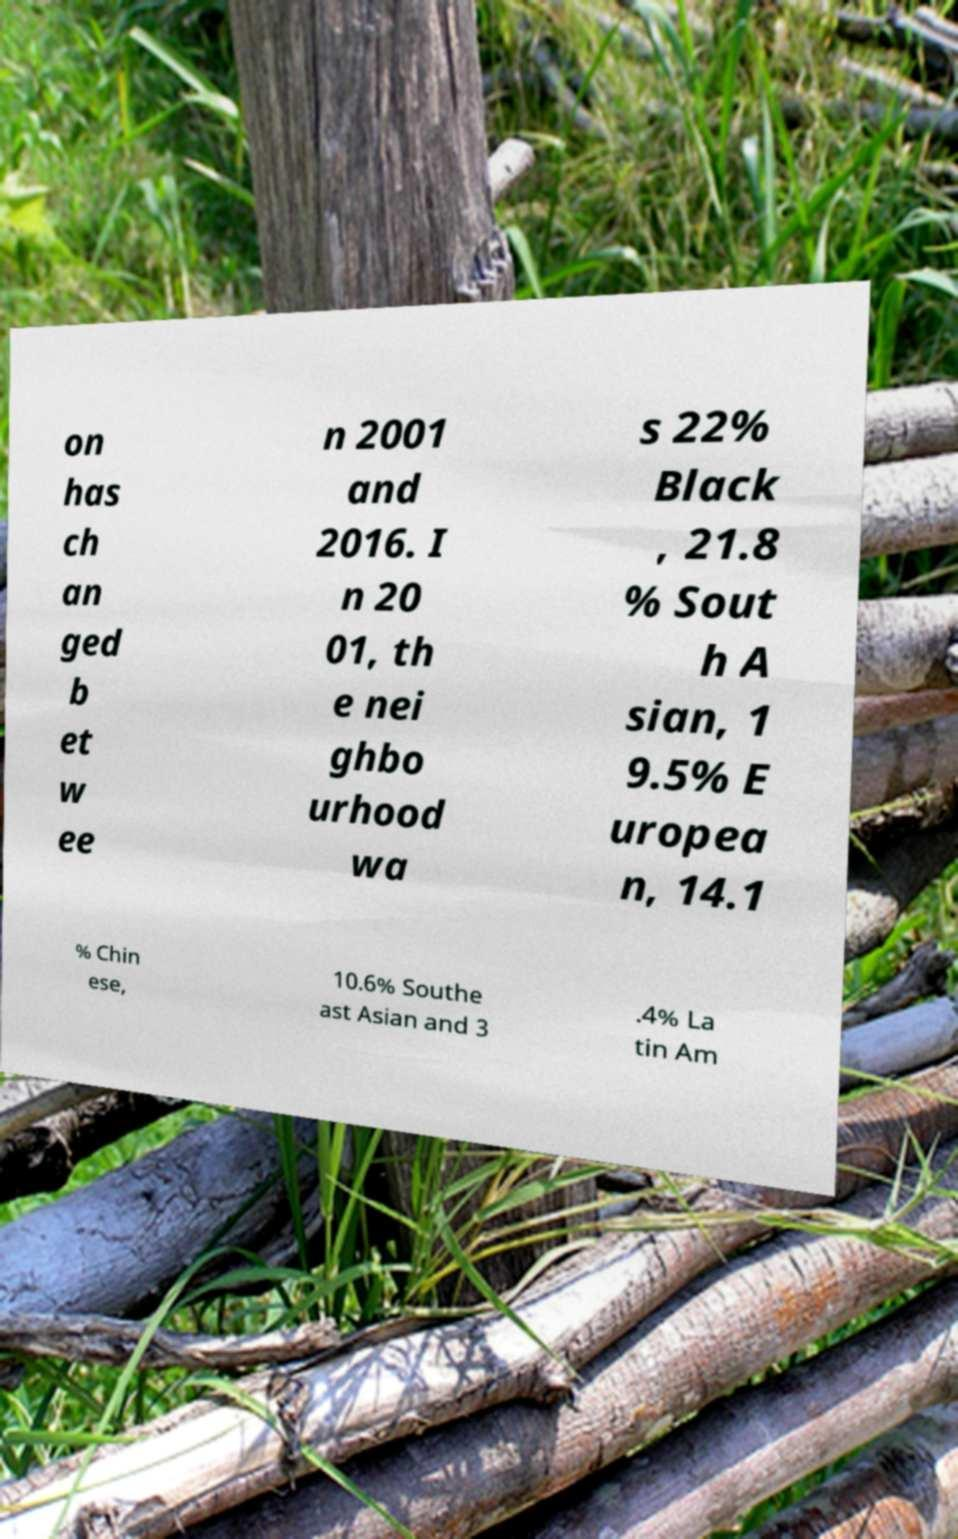Can you read and provide the text displayed in the image?This photo seems to have some interesting text. Can you extract and type it out for me? on has ch an ged b et w ee n 2001 and 2016. I n 20 01, th e nei ghbo urhood wa s 22% Black , 21.8 % Sout h A sian, 1 9.5% E uropea n, 14.1 % Chin ese, 10.6% Southe ast Asian and 3 .4% La tin Am 